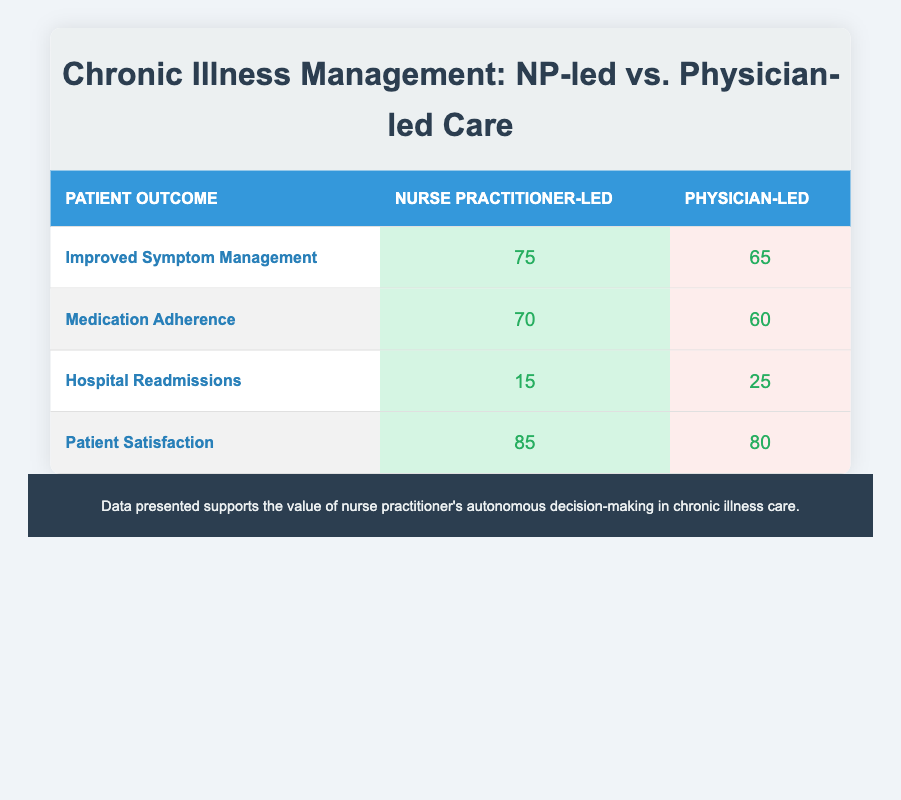What is the count of patients who experienced improved symptom management under nurse practitioner-led care? The table shows that the count for improved symptom management under nurse practitioner-led care is 75.
Answer: 75 What is the total count of hospital readmissions for both care types? The count of hospital readmissions under nurse practitioner-led care is 15 and under physician-led care is 25. Adding these gives 15 + 25 = 40.
Answer: 40 Which care type had a higher count for medication adherence? The table indicates that nurse practitioner-led care had 70 counts, while physician-led care had 60 counts. Since 70 > 60, nurse practitioner-led care had a higher count.
Answer: Nurse practitioner-led Was the patient satisfaction lower in physician-led care compared to nurse practitioner-led care? The count for patient satisfaction under nurse practitioner-led care is 85 and under physician-led care is 80. Since 80 is less than 85, the statement is true.
Answer: Yes What is the difference in patient satisfaction counts between nurse practitioner-led and physician-led care? The table shows patient satisfaction counts of 85 for nurse practitioner-led care and 80 for physician-led care. The difference is 85 - 80 = 5.
Answer: 5 What is the average count for improved symptom management across both care types? The counts for improved symptom management are 75 for nurse practitioner-led and 65 for physician-led care. The average is (75 + 65) / 2 = 70.
Answer: 70 Which patient outcome had the highest count in the nurse practitioner-led care? The counts for nurse practitioner-led care from the table are 75 for improved symptom management, 70 for medication adherence, 15 for hospital readmissions, and 85 for patient satisfaction. The highest count is 85 for patient satisfaction.
Answer: Patient Satisfaction How many fewer patients were readmitted to the hospital under nurse practitioner-led care compared to physician-led care? The readmission count is 15 for nurse practitioner-led care and 25 for physician-led care. The difference is 25 - 15 = 10 fewer patients under nurse practitioner-led care.
Answer: 10 